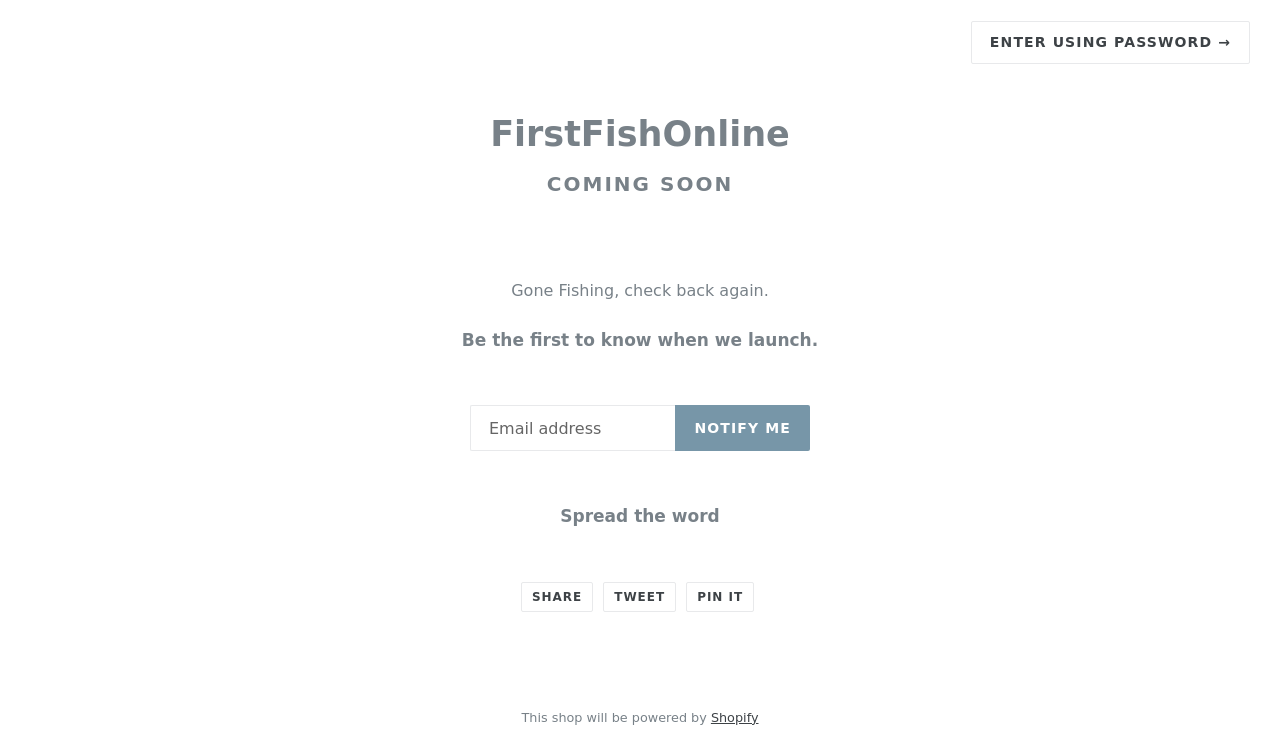What does the phrase 'Gone Fishing, check back again.' mean in this context? The slogan 'Gone Fishing, check back again.' implies that the FirstFishOnline store is currently preparing for launch and isn’t operational yet, similar to a person taking a break by going fishing. It reflects the theme of the store, which might be related to fishing, outdoors, or aquatic themes. 